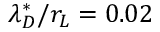Convert formula to latex. <formula><loc_0><loc_0><loc_500><loc_500>\lambda _ { D } ^ { * } / r _ { L } = 0 . 0 2</formula> 